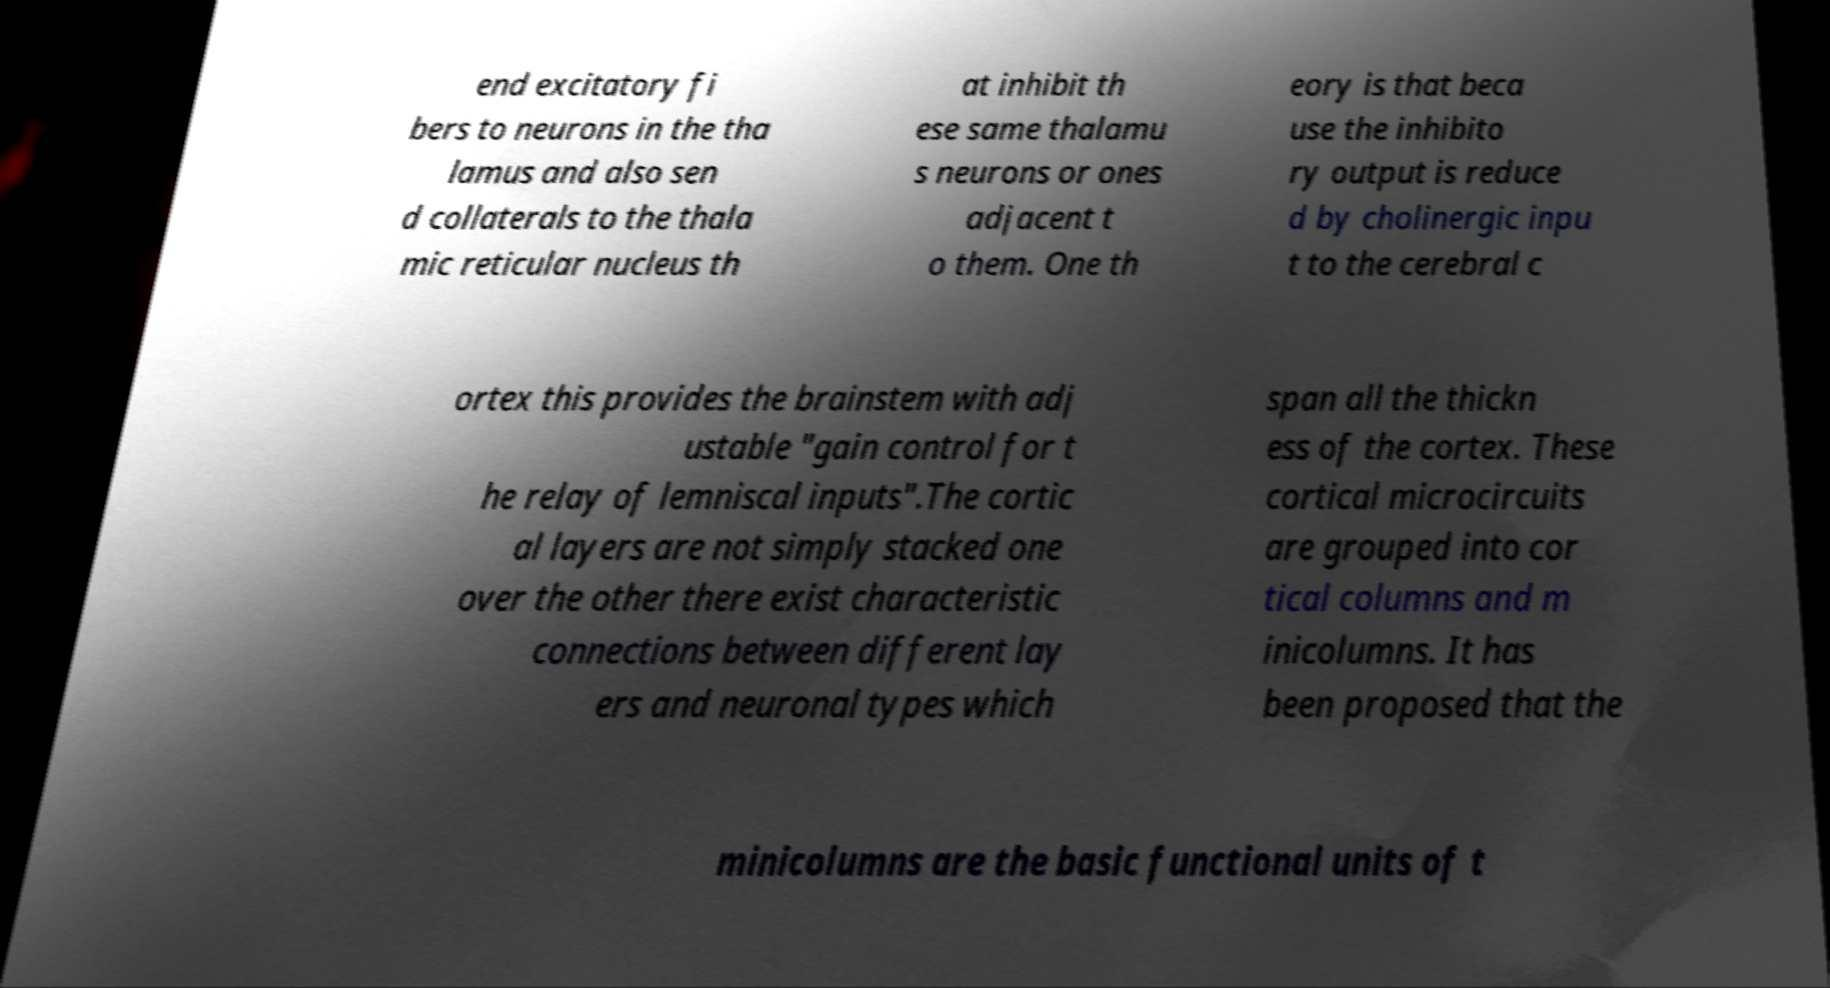There's text embedded in this image that I need extracted. Can you transcribe it verbatim? end excitatory fi bers to neurons in the tha lamus and also sen d collaterals to the thala mic reticular nucleus th at inhibit th ese same thalamu s neurons or ones adjacent t o them. One th eory is that beca use the inhibito ry output is reduce d by cholinergic inpu t to the cerebral c ortex this provides the brainstem with adj ustable "gain control for t he relay of lemniscal inputs".The cortic al layers are not simply stacked one over the other there exist characteristic connections between different lay ers and neuronal types which span all the thickn ess of the cortex. These cortical microcircuits are grouped into cor tical columns and m inicolumns. It has been proposed that the minicolumns are the basic functional units of t 